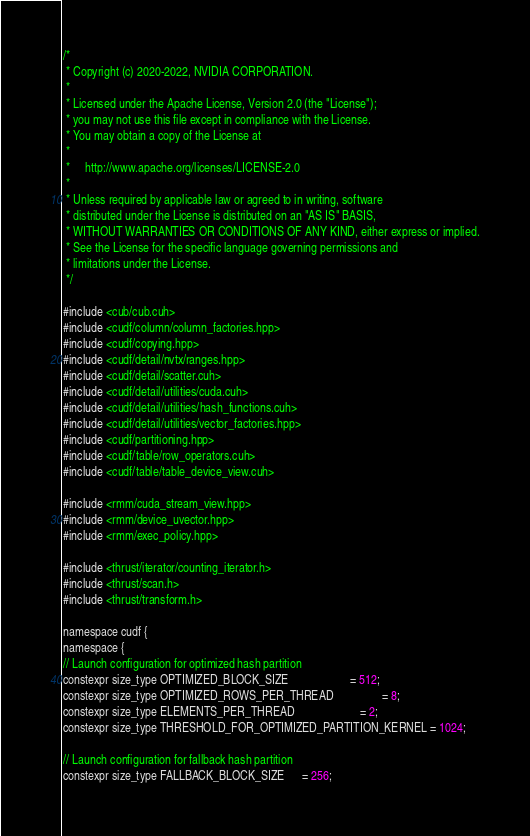Convert code to text. <code><loc_0><loc_0><loc_500><loc_500><_Cuda_>/*
 * Copyright (c) 2020-2022, NVIDIA CORPORATION.
 *
 * Licensed under the Apache License, Version 2.0 (the "License");
 * you may not use this file except in compliance with the License.
 * You may obtain a copy of the License at
 *
 *     http://www.apache.org/licenses/LICENSE-2.0
 *
 * Unless required by applicable law or agreed to in writing, software
 * distributed under the License is distributed on an "AS IS" BASIS,
 * WITHOUT WARRANTIES OR CONDITIONS OF ANY KIND, either express or implied.
 * See the License for the specific language governing permissions and
 * limitations under the License.
 */

#include <cub/cub.cuh>
#include <cudf/column/column_factories.hpp>
#include <cudf/copying.hpp>
#include <cudf/detail/nvtx/ranges.hpp>
#include <cudf/detail/scatter.cuh>
#include <cudf/detail/utilities/cuda.cuh>
#include <cudf/detail/utilities/hash_functions.cuh>
#include <cudf/detail/utilities/vector_factories.hpp>
#include <cudf/partitioning.hpp>
#include <cudf/table/row_operators.cuh>
#include <cudf/table/table_device_view.cuh>

#include <rmm/cuda_stream_view.hpp>
#include <rmm/device_uvector.hpp>
#include <rmm/exec_policy.hpp>

#include <thrust/iterator/counting_iterator.h>
#include <thrust/scan.h>
#include <thrust/transform.h>

namespace cudf {
namespace {
// Launch configuration for optimized hash partition
constexpr size_type OPTIMIZED_BLOCK_SIZE                     = 512;
constexpr size_type OPTIMIZED_ROWS_PER_THREAD                = 8;
constexpr size_type ELEMENTS_PER_THREAD                      = 2;
constexpr size_type THRESHOLD_FOR_OPTIMIZED_PARTITION_KERNEL = 1024;

// Launch configuration for fallback hash partition
constexpr size_type FALLBACK_BLOCK_SIZE      = 256;</code> 